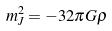<formula> <loc_0><loc_0><loc_500><loc_500>m _ { J } ^ { 2 } = - 3 2 \pi G \rho</formula> 